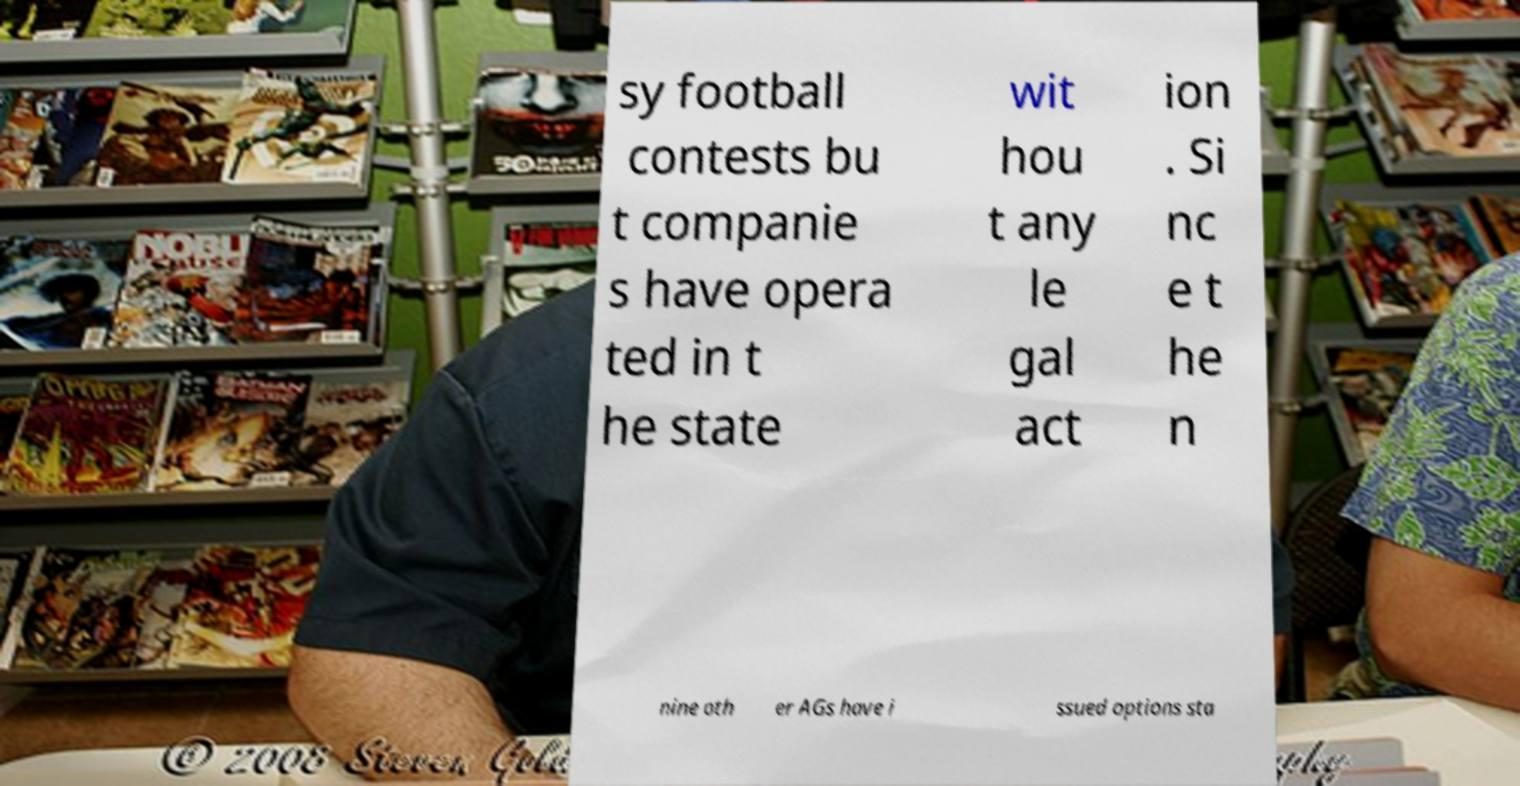Could you extract and type out the text from this image? sy football contests bu t companie s have opera ted in t he state wit hou t any le gal act ion . Si nc e t he n nine oth er AGs have i ssued options sta 